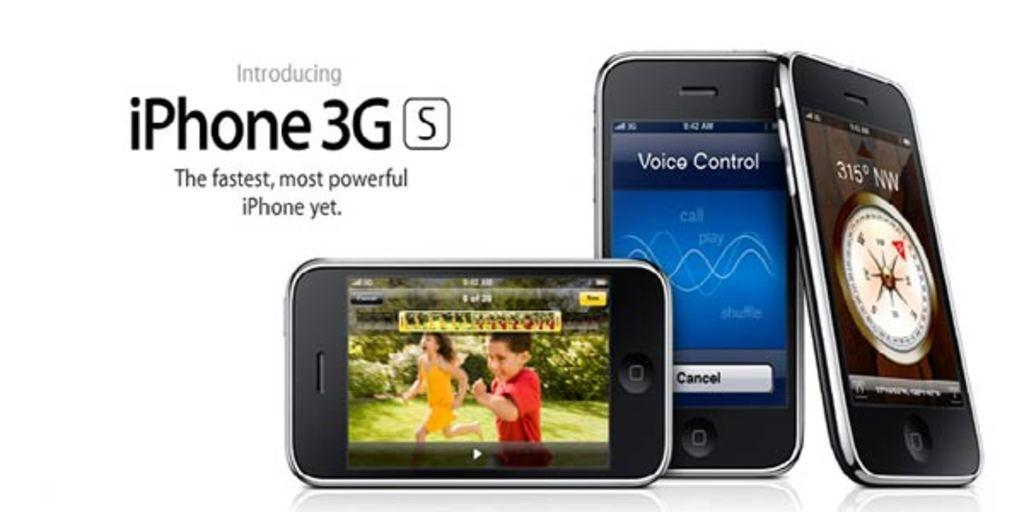Provide a one-sentence caption for the provided image. A row of iPhones are on a white background and the ad says Introducing iPhone 3G S. 